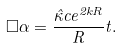Convert formula to latex. <formula><loc_0><loc_0><loc_500><loc_500>\Box \alpha = \frac { \hat { \kappa } c e ^ { 2 k R } } { R } t .</formula> 